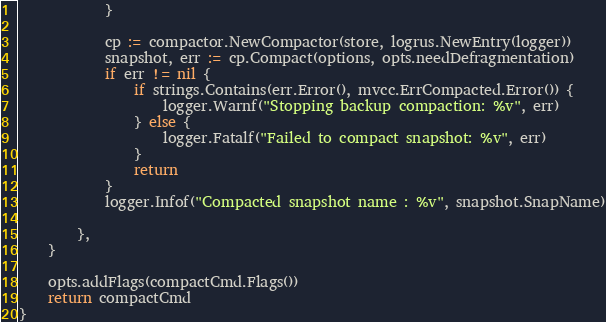Convert code to text. <code><loc_0><loc_0><loc_500><loc_500><_Go_>			}

			cp := compactor.NewCompactor(store, logrus.NewEntry(logger))
			snapshot, err := cp.Compact(options, opts.needDefragmentation)
			if err != nil {
				if strings.Contains(err.Error(), mvcc.ErrCompacted.Error()) {
					logger.Warnf("Stopping backup compaction: %v", err)
				} else {
					logger.Fatalf("Failed to compact snapshot: %v", err)
				}
				return
			}
			logger.Infof("Compacted snapshot name : %v", snapshot.SnapName)

		},
	}

	opts.addFlags(compactCmd.Flags())
	return compactCmd
}
</code> 